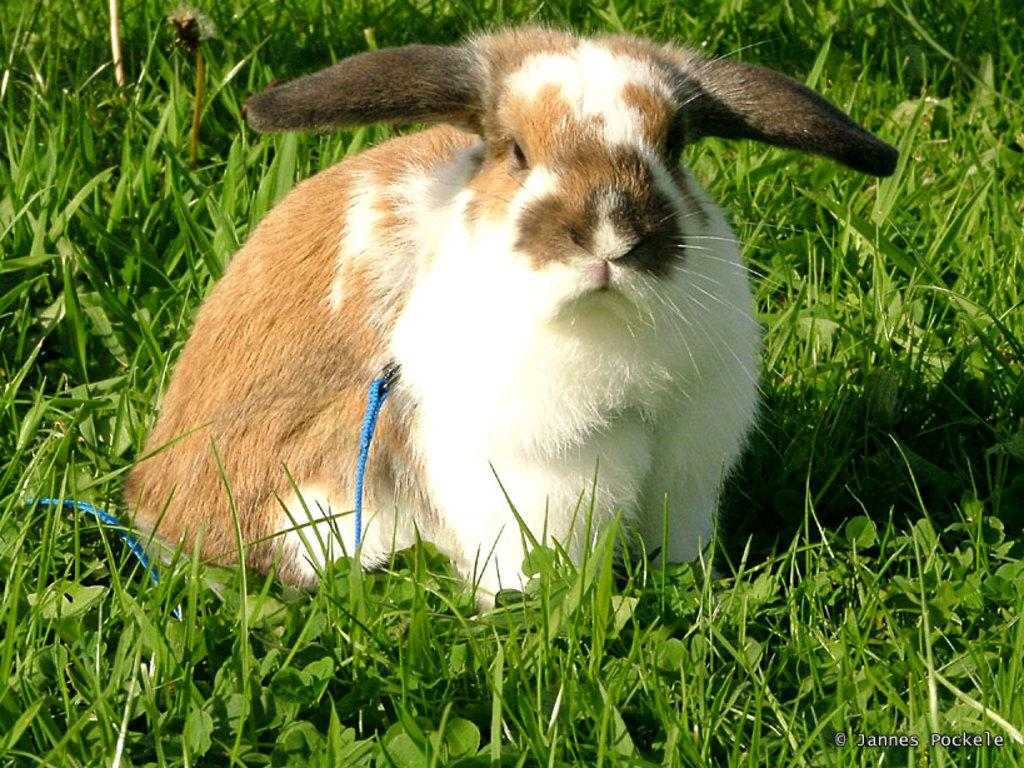What is the main subject in the foreground of the image? There is an animal in the foreground of the image. What is the animal standing on? The animal is on grass. Is there any text present in the image? Yes, there is text in the image. Can you tell if the image was taken during the day or night? The image was likely taken during the day, as there is no indication of darkness or artificial lighting. What type of jam is being spread on the animal in the image? There is no jam or any indication of food in the image; it features an animal on grass with text present. 